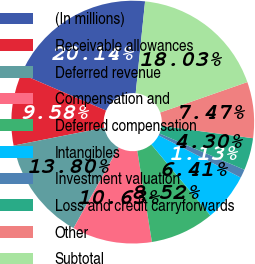<chart> <loc_0><loc_0><loc_500><loc_500><pie_chart><fcel>(In millions)<fcel>Receivable allowances<fcel>Deferred revenue<fcel>Compensation and<fcel>Deferred compensation<fcel>Intangibles<fcel>Investment valuation<fcel>Loss and credit carryforwards<fcel>Other<fcel>Subtotal<nl><fcel>20.14%<fcel>9.58%<fcel>13.8%<fcel>10.63%<fcel>8.52%<fcel>6.41%<fcel>1.13%<fcel>4.3%<fcel>7.47%<fcel>18.03%<nl></chart> 